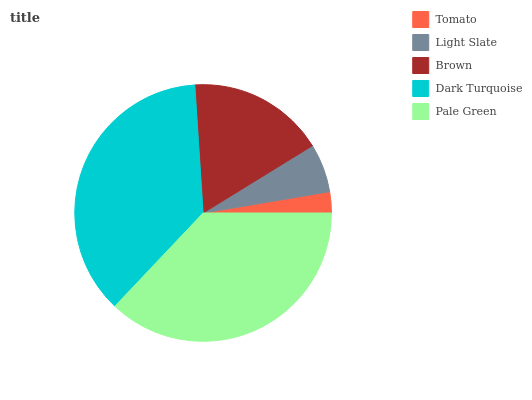Is Tomato the minimum?
Answer yes or no. Yes. Is Pale Green the maximum?
Answer yes or no. Yes. Is Light Slate the minimum?
Answer yes or no. No. Is Light Slate the maximum?
Answer yes or no. No. Is Light Slate greater than Tomato?
Answer yes or no. Yes. Is Tomato less than Light Slate?
Answer yes or no. Yes. Is Tomato greater than Light Slate?
Answer yes or no. No. Is Light Slate less than Tomato?
Answer yes or no. No. Is Brown the high median?
Answer yes or no. Yes. Is Brown the low median?
Answer yes or no. Yes. Is Tomato the high median?
Answer yes or no. No. Is Pale Green the low median?
Answer yes or no. No. 